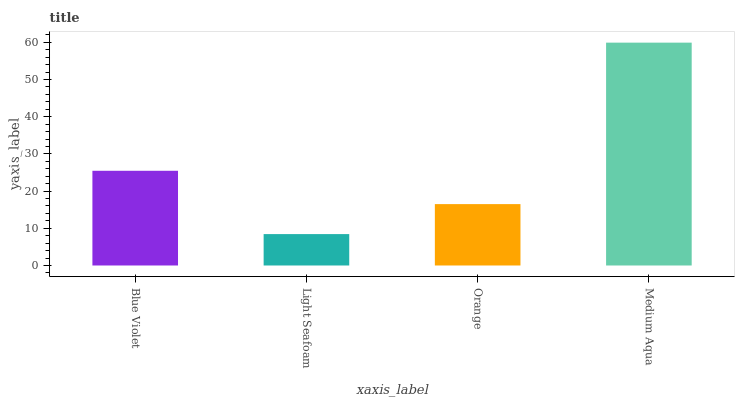Is Light Seafoam the minimum?
Answer yes or no. Yes. Is Medium Aqua the maximum?
Answer yes or no. Yes. Is Orange the minimum?
Answer yes or no. No. Is Orange the maximum?
Answer yes or no. No. Is Orange greater than Light Seafoam?
Answer yes or no. Yes. Is Light Seafoam less than Orange?
Answer yes or no. Yes. Is Light Seafoam greater than Orange?
Answer yes or no. No. Is Orange less than Light Seafoam?
Answer yes or no. No. Is Blue Violet the high median?
Answer yes or no. Yes. Is Orange the low median?
Answer yes or no. Yes. Is Light Seafoam the high median?
Answer yes or no. No. Is Medium Aqua the low median?
Answer yes or no. No. 